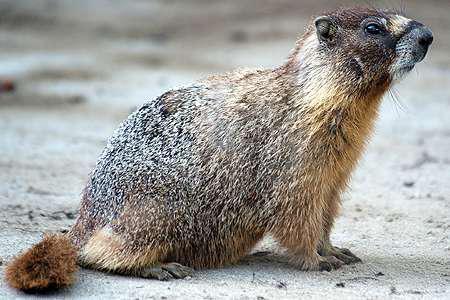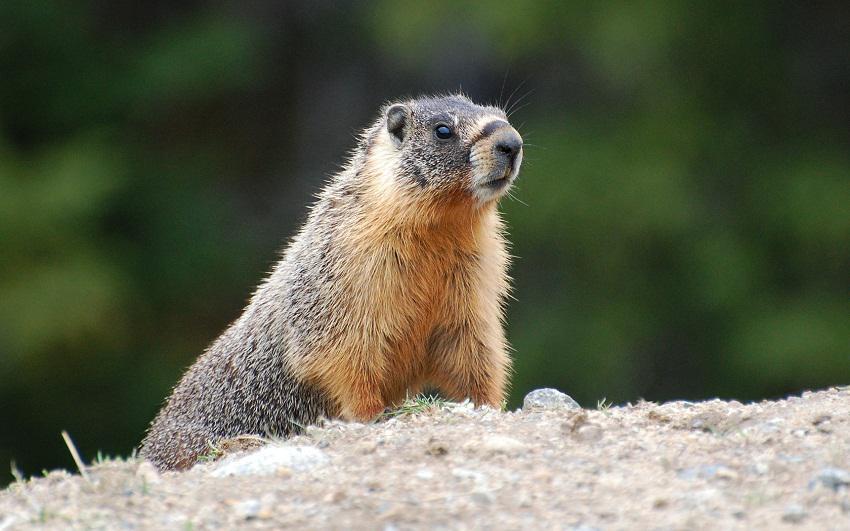The first image is the image on the left, the second image is the image on the right. Considering the images on both sides, is "The animal in the image on the right is not touching the ground with its front paws." valid? Answer yes or no. No. The first image is the image on the left, the second image is the image on the right. For the images displayed, is the sentence "One of the rodents is standing on its hind legs." factually correct? Answer yes or no. No. 